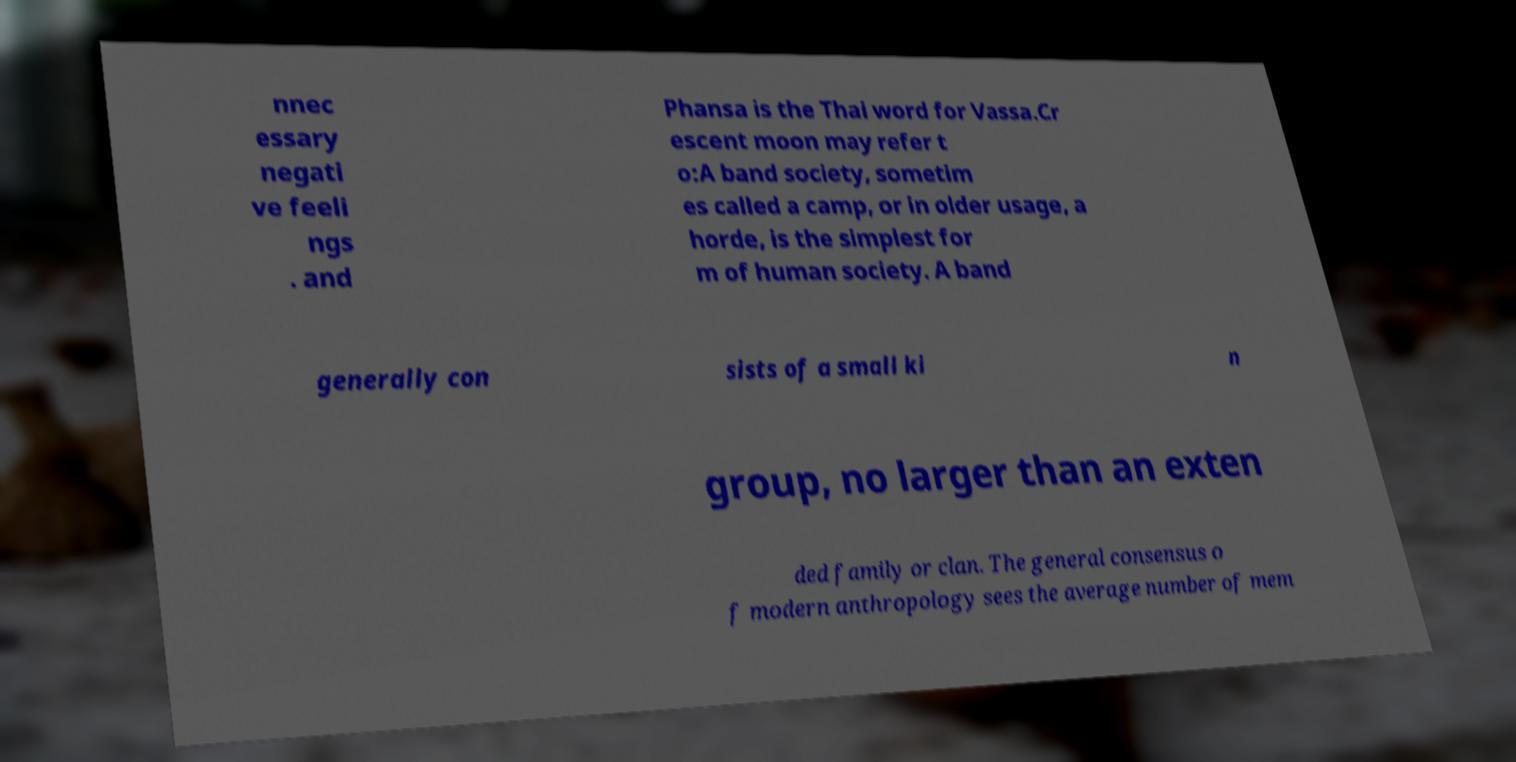Can you accurately transcribe the text from the provided image for me? nnec essary negati ve feeli ngs . and Phansa is the Thai word for Vassa.Cr escent moon may refer t o:A band society, sometim es called a camp, or in older usage, a horde, is the simplest for m of human society. A band generally con sists of a small ki n group, no larger than an exten ded family or clan. The general consensus o f modern anthropology sees the average number of mem 